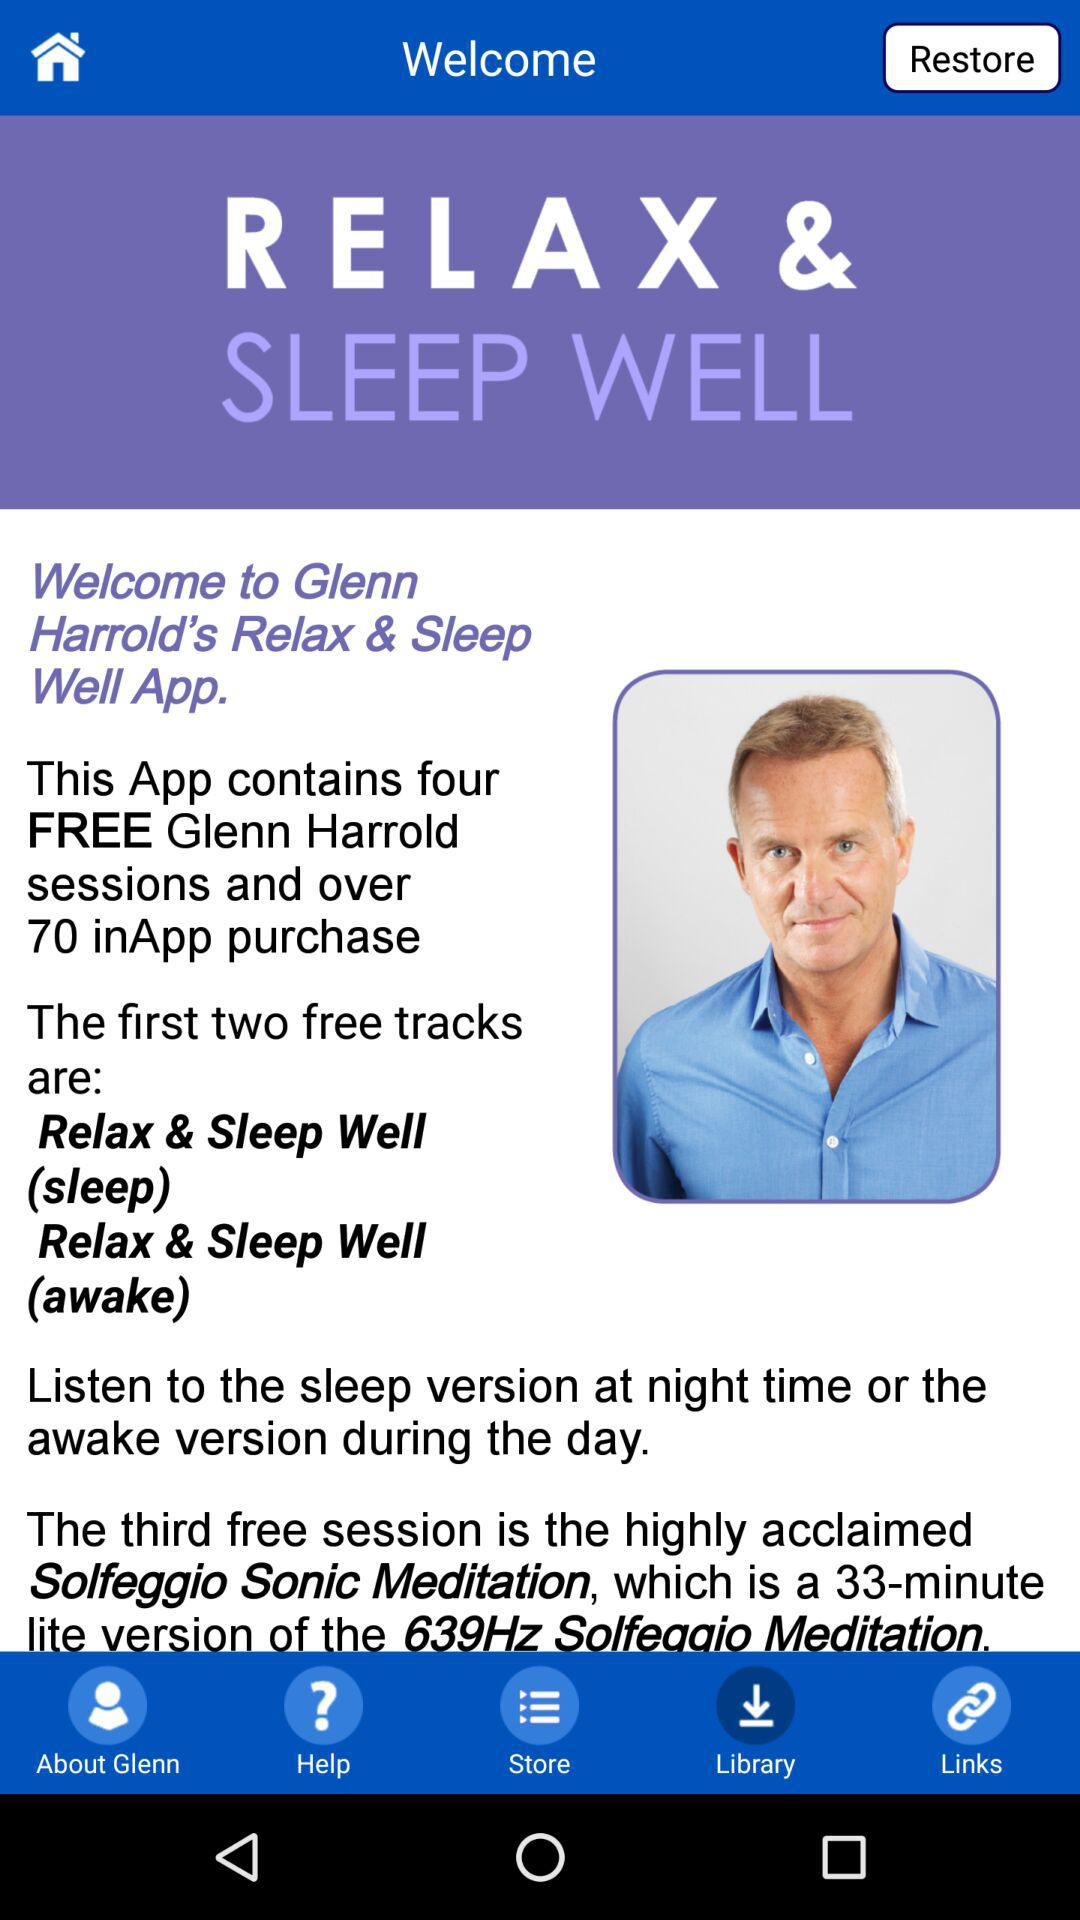What are the first two free tracks? The first two free tracks are "Relax & Sleep Well (sleep)" and "Relax & Sleep Well (awake)". 